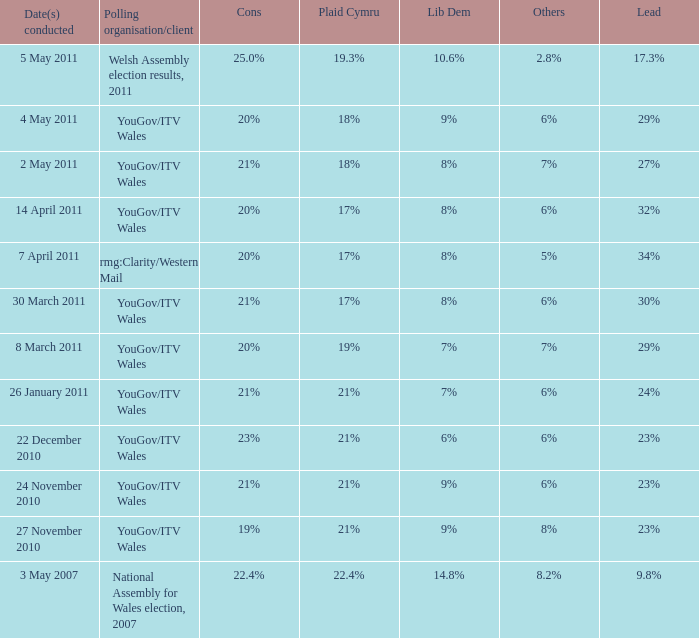I want the plaid cymru for Polling organisation/client of yougov/itv wales for 4 may 2011 18%. 